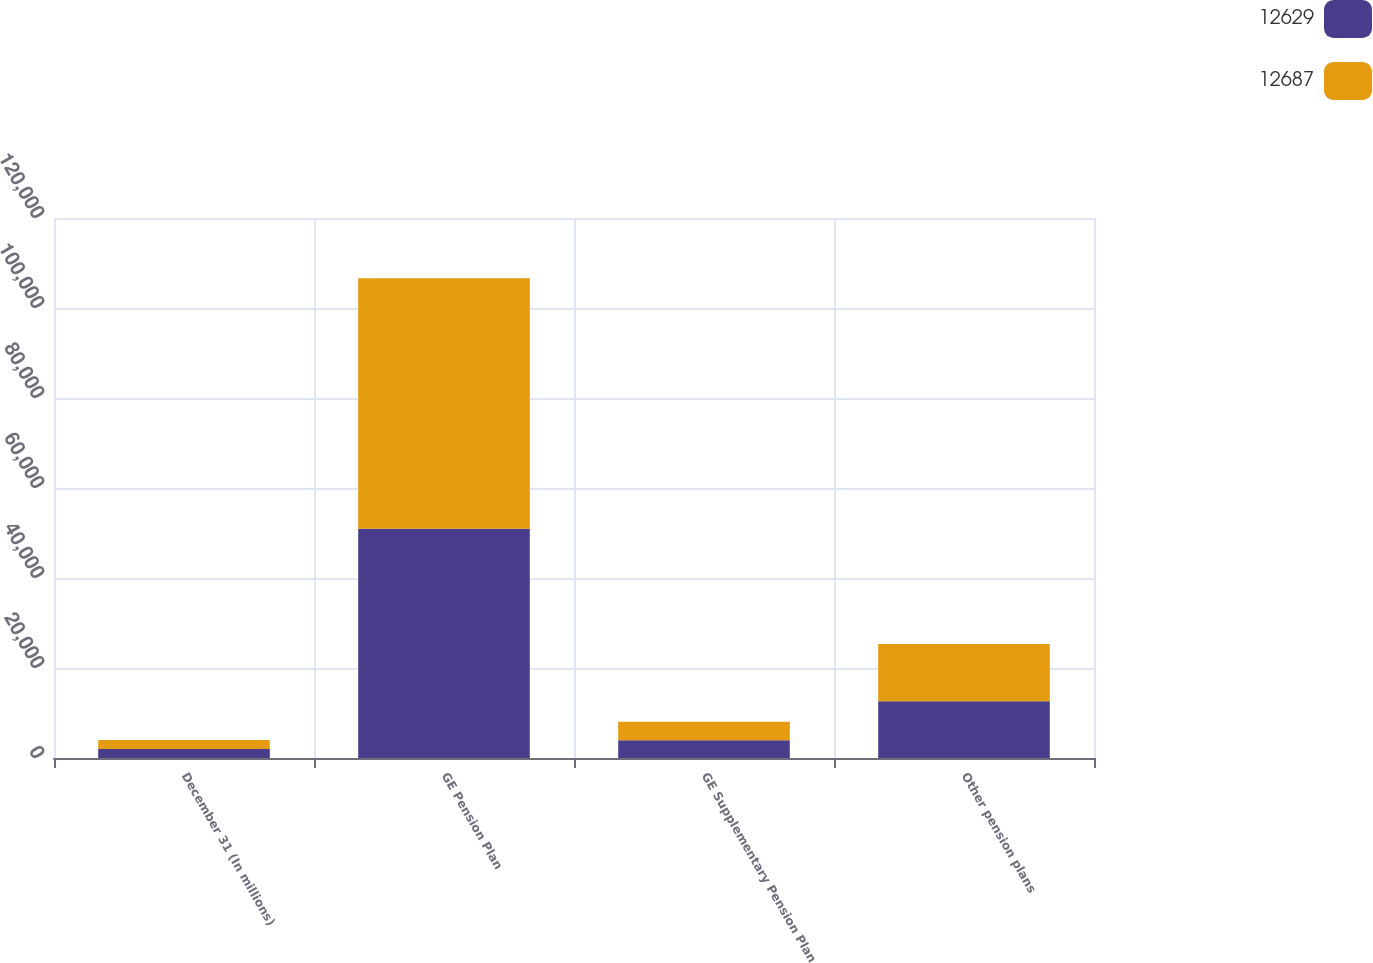Convert chart to OTSL. <chart><loc_0><loc_0><loc_500><loc_500><stacked_bar_chart><ecel><fcel>December 31 (In millions)<fcel>GE Pension Plan<fcel>GE Supplementary Pension Plan<fcel>Other pension plans<nl><fcel>12629<fcel>2013<fcel>50967<fcel>3946<fcel>12629<nl><fcel>12687<fcel>2012<fcel>55664<fcel>4114<fcel>12687<nl></chart> 